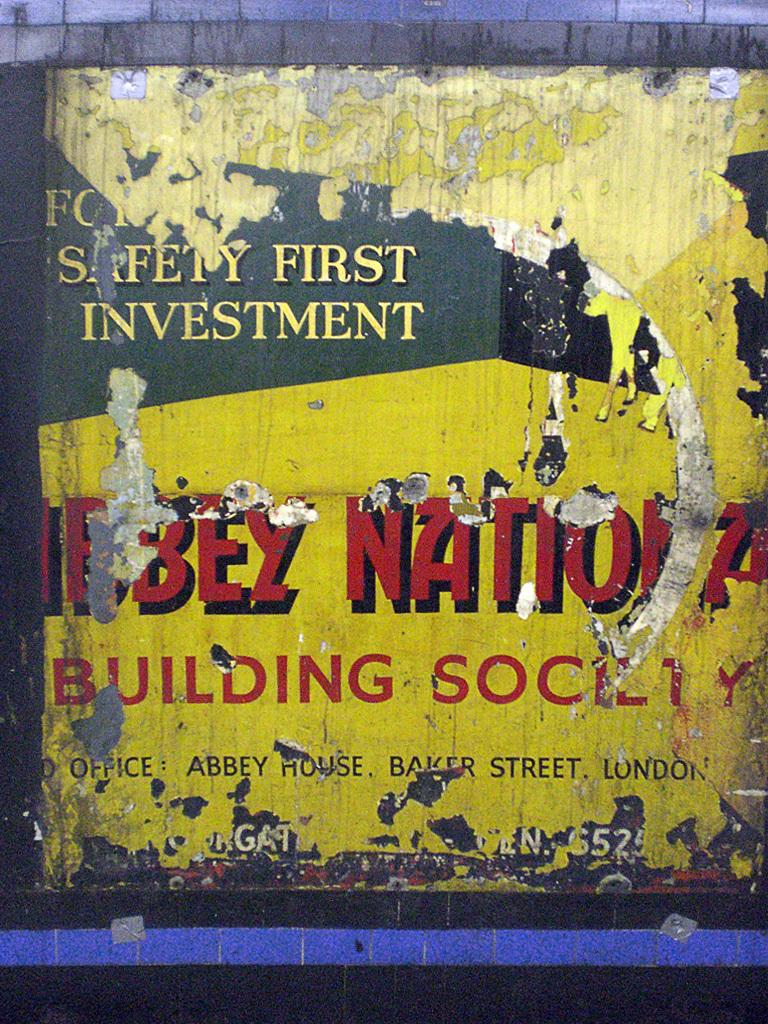<image>
Provide a brief description of the given image. A ripped up sign on a wall mentioning the words building society. 